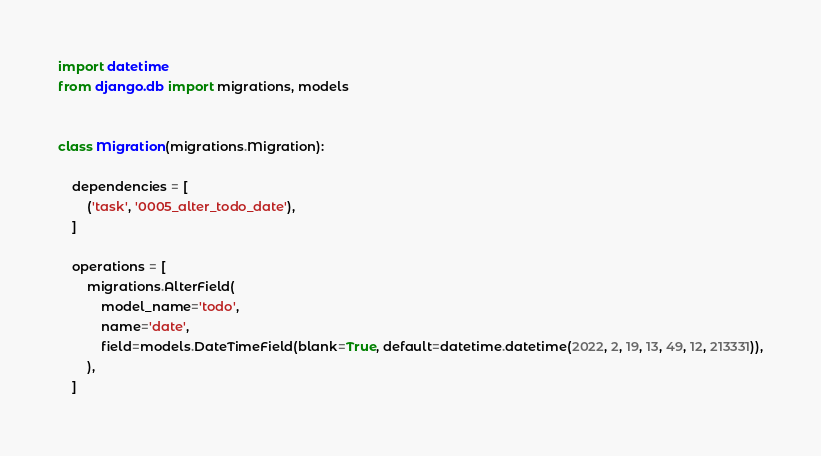Convert code to text. <code><loc_0><loc_0><loc_500><loc_500><_Python_>import datetime
from django.db import migrations, models


class Migration(migrations.Migration):

    dependencies = [
        ('task', '0005_alter_todo_date'),
    ]

    operations = [
        migrations.AlterField(
            model_name='todo',
            name='date',
            field=models.DateTimeField(blank=True, default=datetime.datetime(2022, 2, 19, 13, 49, 12, 213331)),
        ),
    ]
</code> 